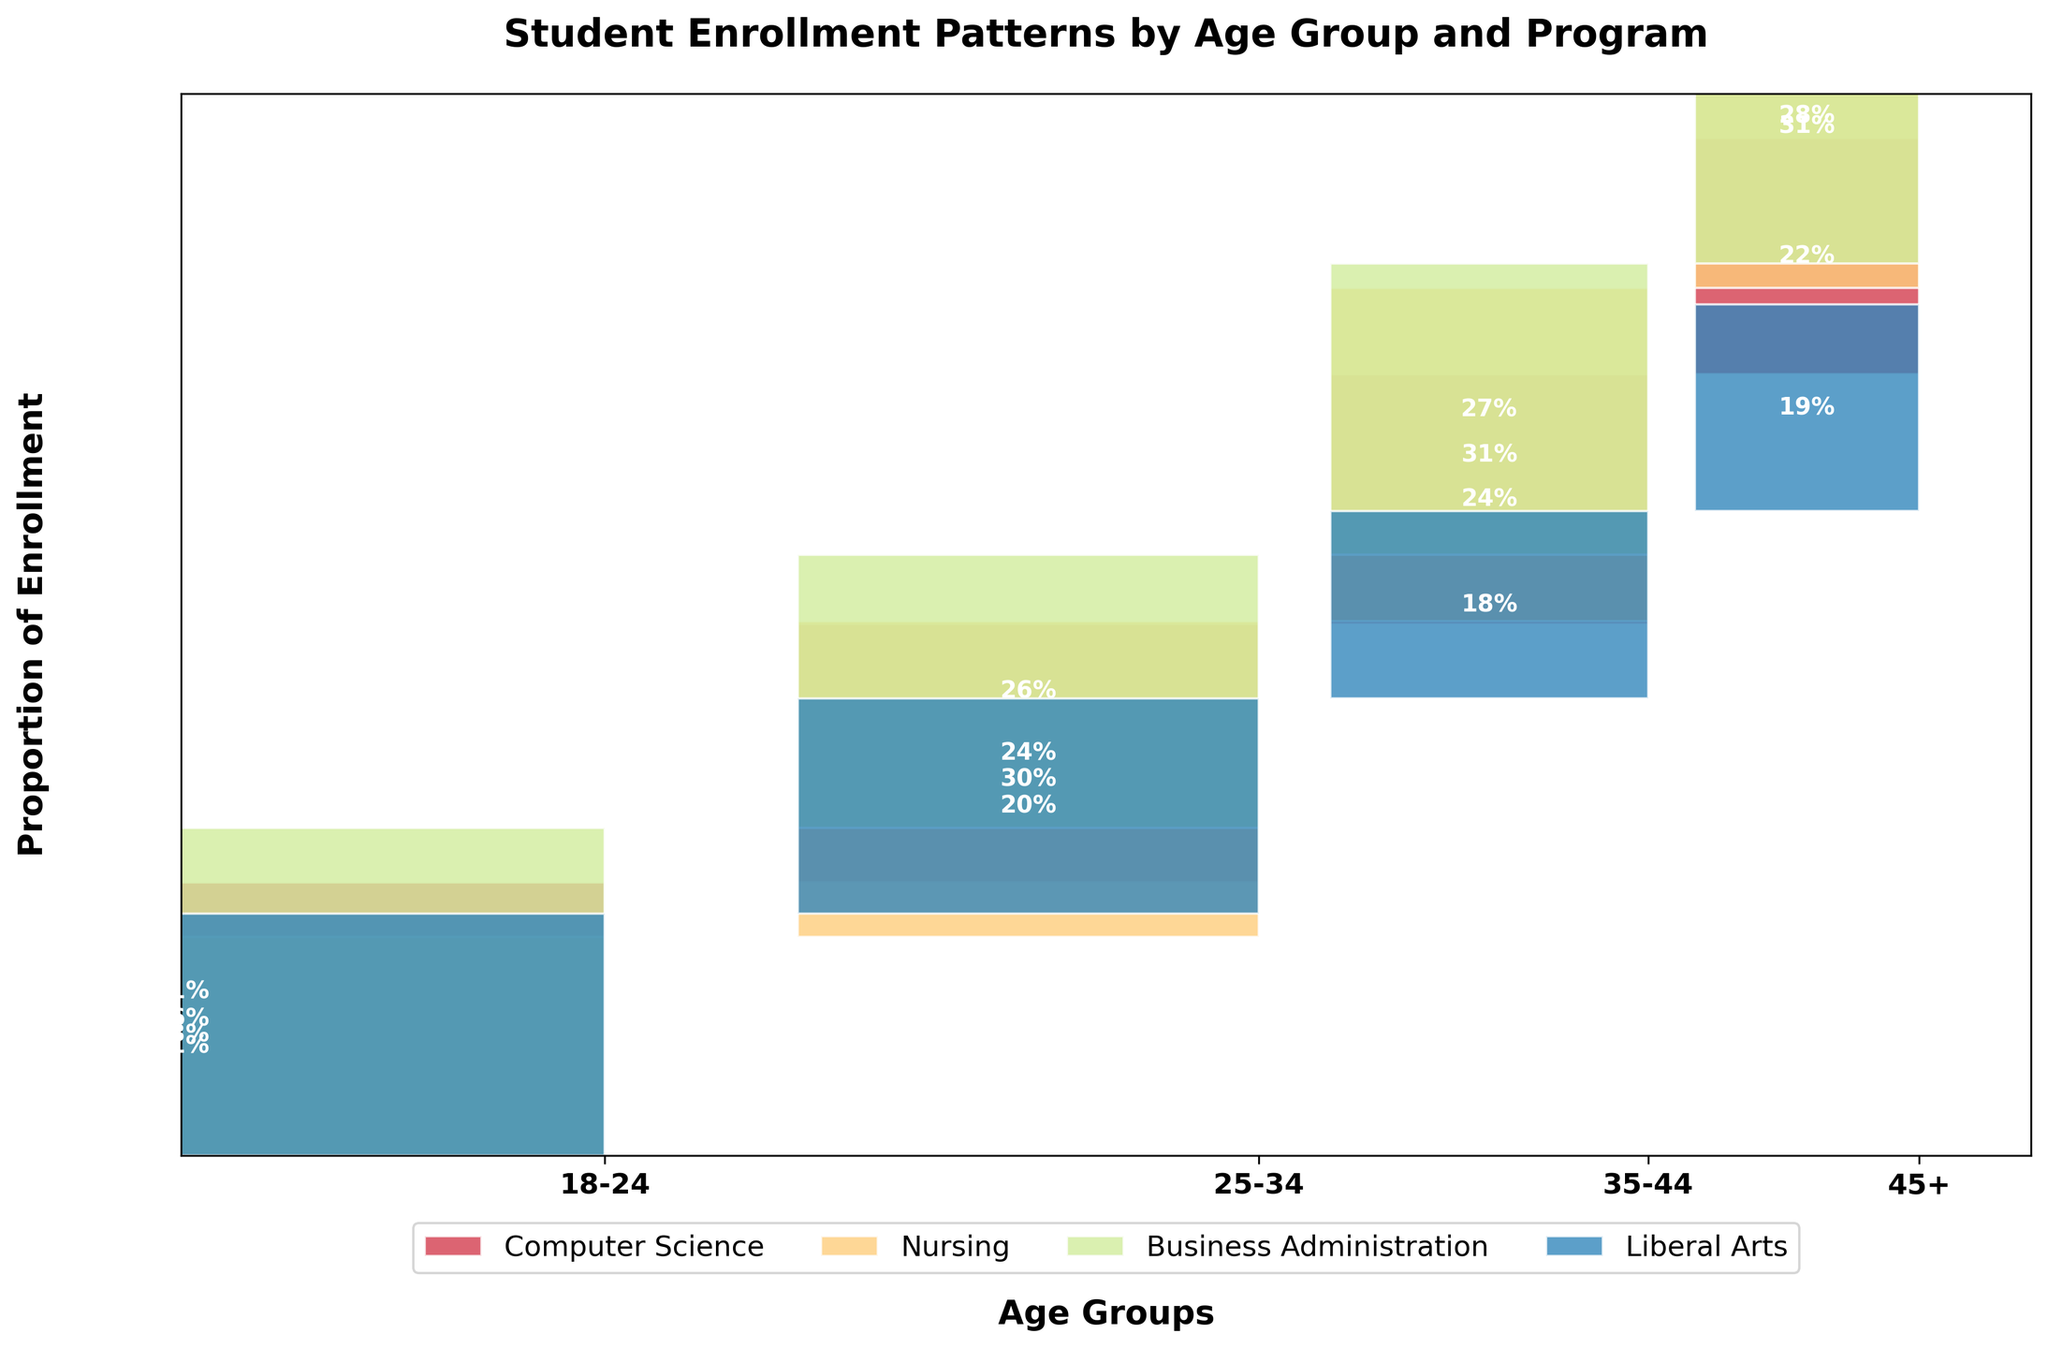What is the title of the figure? The title of the plot is shown at the top in a bold and slightly larger font than the rest of the text.
Answer: Student Enrollment Patterns by Age Group and Program How many age groups are represented in the plot? Count the unique labels along the x-axis representing different age groups.
Answer: Four Which age group has the largest width in the plot? The width of each age group corresponds to the proportion of total enrollment, larger widths indicate higher enrollment. Refer to the x-axis regions with larger widths.
Answer: 18-24 Which age group has the lowest proportion of Computer Science enrollments? Compare the height of the Computer Science segment for each age group. The least substantial height indicates the lowest proportion.
Answer: 45+ In the 18-24 age group, which program has the highest enrollment proportion? Look at the segments for the 18-24 age group and identify which is the tallest.
Answer: Business Administration In the 25-34 age group, are there more students enrolled in Nursing or Liberal Arts? Compare the height of the Nursing and Liberal Arts segments in the 25-34 age group.
Answer: Nursing Is the proportion of students enrolled in Business Administration higher in the 35-44 age group or the 45+ age group? Compare the Business Administration segment heights between the two mentioned age groups.
Answer: 35-44 Which program has the most balanced enrollment proportion across all age groups? Determine balance by comparing the relative heights of program segments; the most balanced program will have more uniform heights across all age groups.
Answer: Nursing 